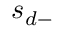Convert formula to latex. <formula><loc_0><loc_0><loc_500><loc_500>s _ { d - }</formula> 